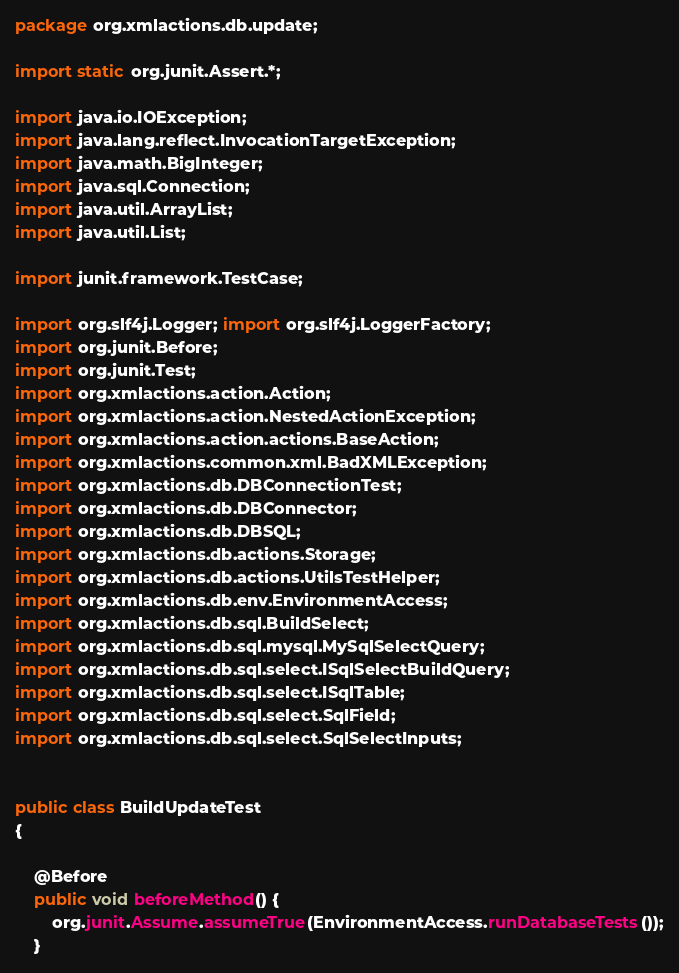Convert code to text. <code><loc_0><loc_0><loc_500><loc_500><_Java_>
package org.xmlactions.db.update;

import static org.junit.Assert.*;

import java.io.IOException;
import java.lang.reflect.InvocationTargetException;
import java.math.BigInteger;
import java.sql.Connection;
import java.util.ArrayList;
import java.util.List;

import junit.framework.TestCase;

import org.slf4j.Logger; import org.slf4j.LoggerFactory;
import org.junit.Before;
import org.junit.Test;
import org.xmlactions.action.Action;
import org.xmlactions.action.NestedActionException;
import org.xmlactions.action.actions.BaseAction;
import org.xmlactions.common.xml.BadXMLException;
import org.xmlactions.db.DBConnectionTest;
import org.xmlactions.db.DBConnector;
import org.xmlactions.db.DBSQL;
import org.xmlactions.db.actions.Storage;
import org.xmlactions.db.actions.UtilsTestHelper;
import org.xmlactions.db.env.EnvironmentAccess;
import org.xmlactions.db.sql.BuildSelect;
import org.xmlactions.db.sql.mysql.MySqlSelectQuery;
import org.xmlactions.db.sql.select.ISqlSelectBuildQuery;
import org.xmlactions.db.sql.select.ISqlTable;
import org.xmlactions.db.sql.select.SqlField;
import org.xmlactions.db.sql.select.SqlSelectInputs;


public class BuildUpdateTest 
{
	
	@Before
	public void beforeMethod() {
		org.junit.Assume.assumeTrue(EnvironmentAccess.runDatabaseTests());
	}
</code> 